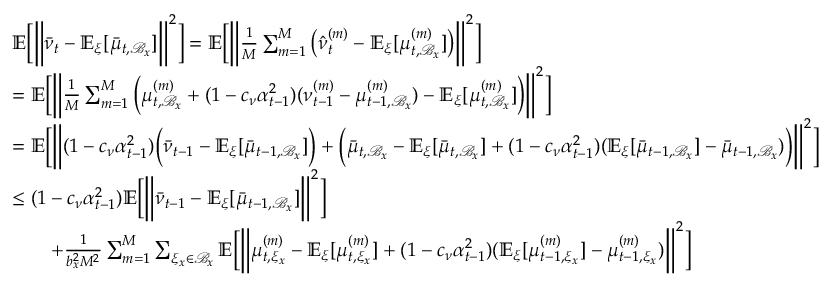<formula> <loc_0><loc_0><loc_500><loc_500>\begin{array} { r l } & { \mathbb { E } \left [ \left \| \bar { \nu } _ { t } - \mathbb { E } _ { \xi } [ \bar { \mu } _ { t , \mathcal { B } _ { x } } ] \right \| ^ { 2 } \right ] = \mathbb { E } \left [ \left \| \frac { 1 } { M } \sum _ { m = 1 } ^ { M } \left ( \hat { \nu } _ { t } ^ { ( m ) } - \mathbb { E } _ { \xi } [ \mu _ { t , \mathcal { B } _ { x } } ^ { ( m ) } ] \right ) \right \| ^ { 2 } \right ] } \\ & { = \mathbb { E } \left [ \left \| \frac { 1 } { M } \sum _ { m = 1 } ^ { M } \left ( \mu _ { t , \mathcal { B } _ { x } } ^ { ( m ) } + ( 1 - c _ { \nu } \alpha _ { t - 1 } ^ { 2 } ) ( \nu _ { t - 1 } ^ { ( m ) } - \mu _ { t - 1 , \mathcal { B } _ { x } } ^ { ( m ) } ) - \mathbb { E } _ { \xi } [ \mu _ { t , \mathcal { B } _ { x } } ^ { ( m ) } ] \right ) \right \| ^ { 2 } \right ] } \\ & { = \mathbb { E } \left [ \left \| ( 1 - c _ { \nu } \alpha _ { t - 1 } ^ { 2 } ) \left ( \bar { \nu } _ { t - 1 } - \mathbb { E } _ { \xi } [ \bar { \mu } _ { t - 1 , \mathcal { B } _ { x } } ] \right ) + \left ( \bar { \mu } _ { t , \mathcal { B } _ { x } } - \mathbb { E } _ { \xi } [ \bar { \mu } _ { t , \mathcal { B } _ { x } } ] + ( 1 - c _ { \nu } \alpha _ { t - 1 } ^ { 2 } ) ( \mathbb { E } _ { \xi } [ \bar { \mu } _ { t - 1 , \mathcal { B } _ { x } } ] - \bar { \mu } _ { t - 1 , \mathcal { B } _ { x } } ) \right ) \right \| ^ { 2 } \right ] } \\ & { \leq ( 1 - c _ { \nu } \alpha _ { t - 1 } ^ { 2 } ) \mathbb { E } \left [ \left \| \bar { \nu } _ { t - 1 } - \mathbb { E } _ { \xi } [ \bar { \mu } _ { t - 1 , \mathcal { B } _ { x } } ] \right \| ^ { 2 } \right ] } \\ & { \quad + \frac { 1 } { b _ { x } ^ { 2 } M ^ { 2 } } \sum _ { m = 1 } ^ { M } \sum _ { \xi _ { x } \in \mathcal { B } _ { x } } \mathbb { E } \left [ \left \| \mu _ { t , \xi _ { x } } ^ { ( m ) } - \mathbb { E } _ { \xi } [ \mu _ { t , \xi _ { x } } ^ { ( m ) } ] + ( 1 - c _ { \nu } \alpha _ { t - 1 } ^ { 2 } ) ( \mathbb { E } _ { \xi } [ \mu _ { t - 1 , \xi _ { x } } ^ { ( m ) } ] - \mu _ { t - 1 , \xi _ { x } } ^ { ( m ) } ) \right \| ^ { 2 } \right ] } \end{array}</formula> 